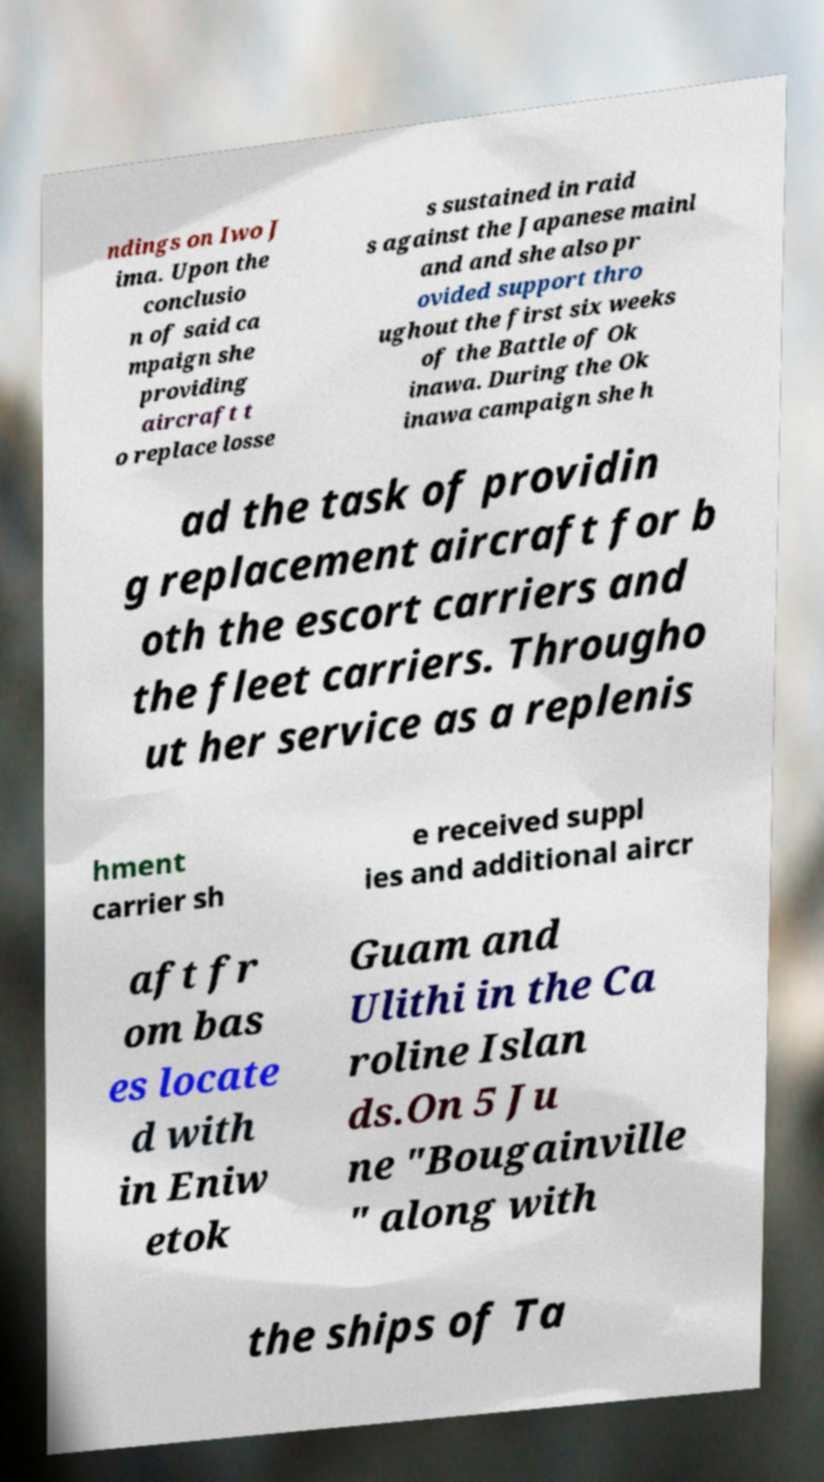Can you accurately transcribe the text from the provided image for me? ndings on Iwo J ima. Upon the conclusio n of said ca mpaign she providing aircraft t o replace losse s sustained in raid s against the Japanese mainl and and she also pr ovided support thro ughout the first six weeks of the Battle of Ok inawa. During the Ok inawa campaign she h ad the task of providin g replacement aircraft for b oth the escort carriers and the fleet carriers. Througho ut her service as a replenis hment carrier sh e received suppl ies and additional aircr aft fr om bas es locate d with in Eniw etok Guam and Ulithi in the Ca roline Islan ds.On 5 Ju ne "Bougainville " along with the ships of Ta 